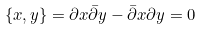<formula> <loc_0><loc_0><loc_500><loc_500>\{ x , y \} = \partial x \bar { \partial } y - \bar { \partial } x \partial y = 0</formula> 